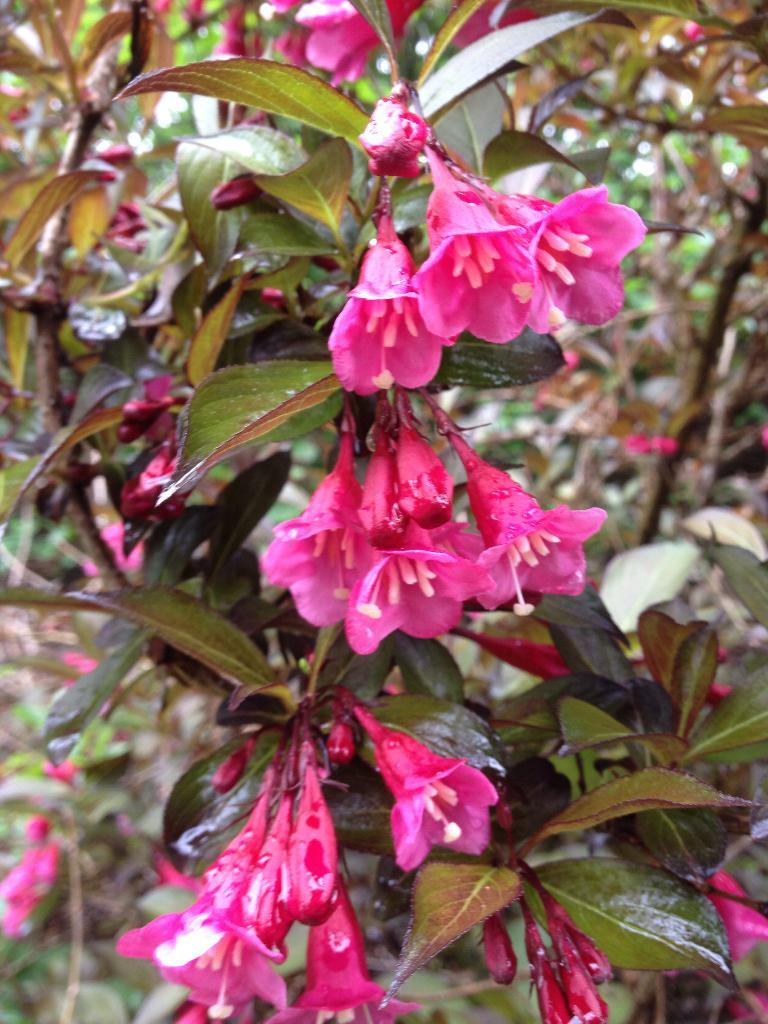What type of plant life is present in the image? There are stems with leaves and flowers in the image. Are there any unopened flowers in the image? Yes, there are buds in the image. How would you describe the background of the image? The background of the image is blurred. What type of stew is being prepared in the image? There is no stew present in the image; it features plant life with stems, leaves, flowers, and buds. How often should the flowers be washed in the image? There is no need to wash the flowers in the image, as they are not real and are part of a photograph or illustration. 